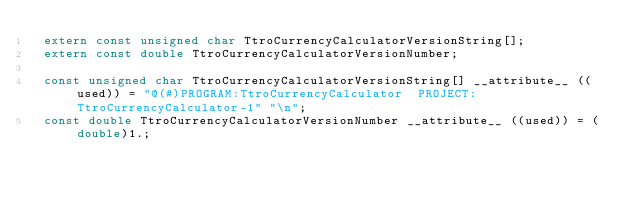Convert code to text. <code><loc_0><loc_0><loc_500><loc_500><_C_> extern const unsigned char TtroCurrencyCalculatorVersionString[];
 extern const double TtroCurrencyCalculatorVersionNumber;

 const unsigned char TtroCurrencyCalculatorVersionString[] __attribute__ ((used)) = "@(#)PROGRAM:TtroCurrencyCalculator  PROJECT:TtroCurrencyCalculator-1" "\n";
 const double TtroCurrencyCalculatorVersionNumber __attribute__ ((used)) = (double)1.;
</code> 